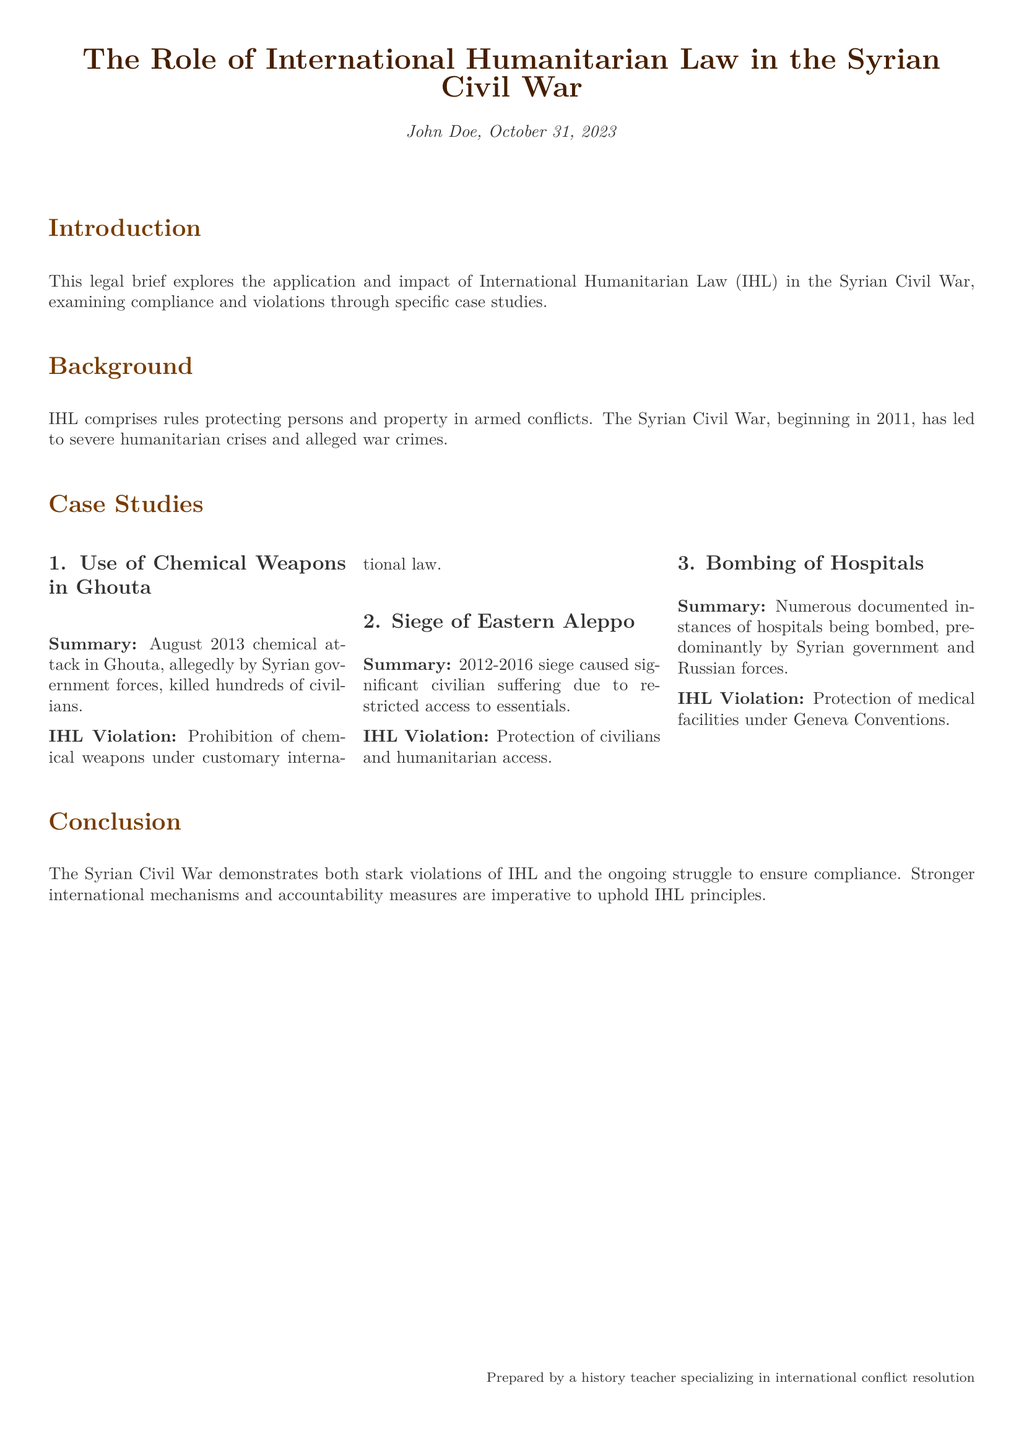what is the focus of the legal brief? The focus is on the application and impact of International Humanitarian Law in the Syrian Civil War.
Answer: International Humanitarian Law in the Syrian Civil War which year did the Syrian Civil War begin? The document states the war began in 2011.
Answer: 2011 what event does the first case study discuss? The first case study discusses a chemical attack in Ghouta.
Answer: chemical attack in Ghouta what is one IHL violation mentioned in relation to the siege of Eastern Aleppo? The document mentions the violation pertains to the protection of civilians and humanitarian access.
Answer: protection of civilians and humanitarian access how many case studies are presented in the document? The document lists three case studies.
Answer: three who is the author of the legal brief? The brief is prepared by John Doe.
Answer: John Doe what type of violations does the bombing of hospitals represent? The violations are related to the protection of medical facilities under the Geneva Conventions.
Answer: protection of medical facilities under Geneva Conventions what is the document's conclusion about compliance with IHL? The conclusion emphasizes the need for stronger international mechanisms and accountability measures.
Answer: stronger international mechanisms and accountability measures 